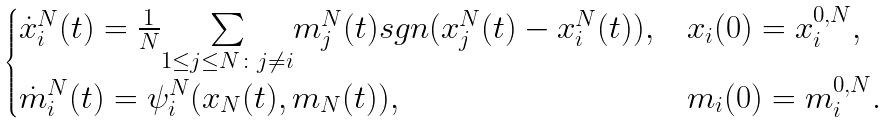<formula> <loc_0><loc_0><loc_500><loc_500>\begin{cases} \dot { x } _ { i } ^ { N } ( t ) = \frac { 1 } { N } \underset { 1 \leq j \leq N \colon j \neq i } { \sum } m _ { j } ^ { N } ( t ) s g n ( x _ { j } ^ { N } ( t ) - x _ { i } ^ { N } ( t ) ) , & x _ { i } ( 0 ) = x _ { i } ^ { 0 , N } , \\ \dot { m } _ { i } ^ { N } ( t ) = \psi _ { i } ^ { N } ( x _ { N } ( t ) , m _ { N } ( t ) ) , & m _ { i } ( 0 ) = m _ { i } ^ { 0 , N } . \end{cases}</formula> 